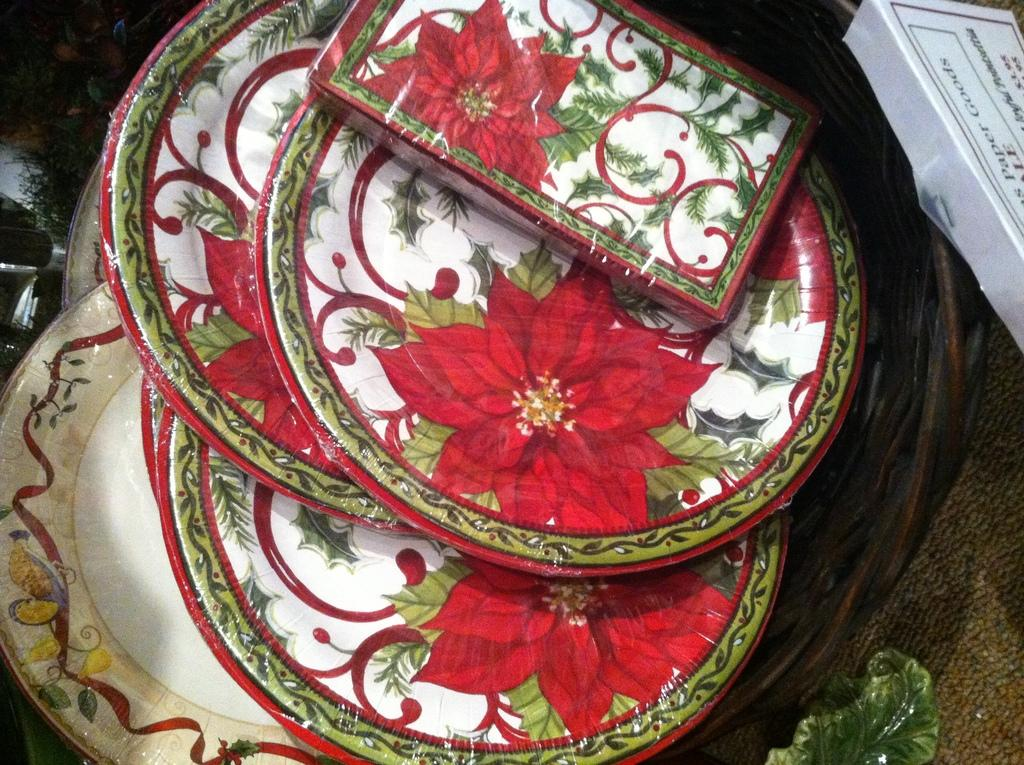What type of dishware is present in the image? There is a set of ceramic plates in the image. What type of plant material is visible in the image? There is a leaf in the image. What type of container is present in the image? There is a white box in the image. What type of worm can be seen crawling on the ceramic plates in the image? There is no worm present in the image; it only features a set of ceramic plates, a leaf, and a white box. What type of behavior is exhibited by the leaf in the image? The leaf is an inanimate object and does not exhibit any behavior in the image. 